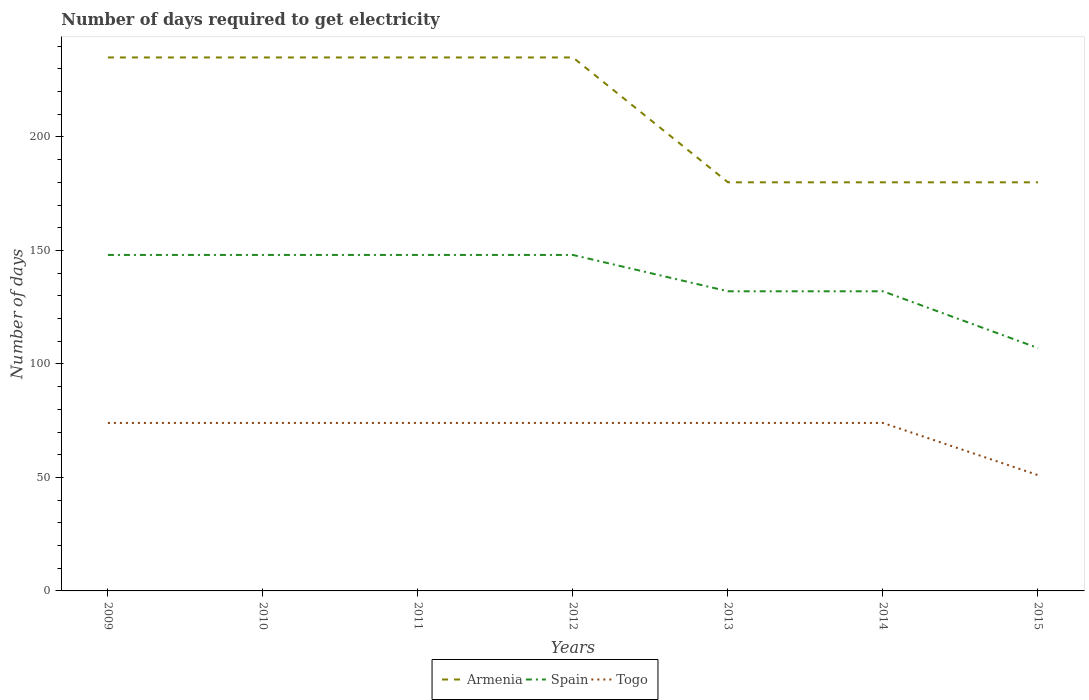How many different coloured lines are there?
Provide a succinct answer. 3. Is the number of lines equal to the number of legend labels?
Keep it short and to the point. Yes. Across all years, what is the maximum number of days required to get electricity in in Spain?
Provide a short and direct response. 107. What is the total number of days required to get electricity in in Togo in the graph?
Offer a terse response. 0. What is the difference between the highest and the second highest number of days required to get electricity in in Armenia?
Your response must be concise. 55. Is the number of days required to get electricity in in Spain strictly greater than the number of days required to get electricity in in Togo over the years?
Ensure brevity in your answer.  No. How many years are there in the graph?
Your response must be concise. 7. What is the difference between two consecutive major ticks on the Y-axis?
Provide a succinct answer. 50. Are the values on the major ticks of Y-axis written in scientific E-notation?
Ensure brevity in your answer.  No. Does the graph contain any zero values?
Your answer should be compact. No. Where does the legend appear in the graph?
Provide a succinct answer. Bottom center. How are the legend labels stacked?
Your answer should be compact. Horizontal. What is the title of the graph?
Your answer should be compact. Number of days required to get electricity. Does "Ethiopia" appear as one of the legend labels in the graph?
Your answer should be compact. No. What is the label or title of the Y-axis?
Keep it short and to the point. Number of days. What is the Number of days in Armenia in 2009?
Your answer should be compact. 235. What is the Number of days of Spain in 2009?
Give a very brief answer. 148. What is the Number of days of Armenia in 2010?
Your response must be concise. 235. What is the Number of days in Spain in 2010?
Ensure brevity in your answer.  148. What is the Number of days of Armenia in 2011?
Give a very brief answer. 235. What is the Number of days of Spain in 2011?
Provide a short and direct response. 148. What is the Number of days in Armenia in 2012?
Give a very brief answer. 235. What is the Number of days in Spain in 2012?
Your answer should be compact. 148. What is the Number of days of Armenia in 2013?
Ensure brevity in your answer.  180. What is the Number of days of Spain in 2013?
Provide a short and direct response. 132. What is the Number of days of Togo in 2013?
Your answer should be very brief. 74. What is the Number of days in Armenia in 2014?
Provide a short and direct response. 180. What is the Number of days of Spain in 2014?
Offer a terse response. 132. What is the Number of days in Armenia in 2015?
Make the answer very short. 180. What is the Number of days in Spain in 2015?
Offer a terse response. 107. Across all years, what is the maximum Number of days of Armenia?
Your response must be concise. 235. Across all years, what is the maximum Number of days in Spain?
Ensure brevity in your answer.  148. Across all years, what is the maximum Number of days in Togo?
Your answer should be very brief. 74. Across all years, what is the minimum Number of days in Armenia?
Ensure brevity in your answer.  180. Across all years, what is the minimum Number of days in Spain?
Your response must be concise. 107. What is the total Number of days of Armenia in the graph?
Give a very brief answer. 1480. What is the total Number of days in Spain in the graph?
Provide a succinct answer. 963. What is the total Number of days in Togo in the graph?
Offer a terse response. 495. What is the difference between the Number of days of Armenia in 2009 and that in 2010?
Make the answer very short. 0. What is the difference between the Number of days in Spain in 2009 and that in 2010?
Give a very brief answer. 0. What is the difference between the Number of days of Togo in 2009 and that in 2010?
Provide a short and direct response. 0. What is the difference between the Number of days of Armenia in 2009 and that in 2011?
Your answer should be compact. 0. What is the difference between the Number of days of Spain in 2009 and that in 2011?
Your response must be concise. 0. What is the difference between the Number of days of Togo in 2009 and that in 2011?
Provide a succinct answer. 0. What is the difference between the Number of days of Armenia in 2009 and that in 2012?
Your answer should be very brief. 0. What is the difference between the Number of days of Togo in 2009 and that in 2012?
Keep it short and to the point. 0. What is the difference between the Number of days of Armenia in 2009 and that in 2013?
Provide a succinct answer. 55. What is the difference between the Number of days of Togo in 2009 and that in 2013?
Offer a very short reply. 0. What is the difference between the Number of days in Armenia in 2009 and that in 2015?
Offer a very short reply. 55. What is the difference between the Number of days of Togo in 2009 and that in 2015?
Keep it short and to the point. 23. What is the difference between the Number of days in Armenia in 2010 and that in 2011?
Your answer should be compact. 0. What is the difference between the Number of days of Spain in 2010 and that in 2011?
Provide a short and direct response. 0. What is the difference between the Number of days in Togo in 2010 and that in 2011?
Keep it short and to the point. 0. What is the difference between the Number of days of Armenia in 2010 and that in 2012?
Keep it short and to the point. 0. What is the difference between the Number of days in Armenia in 2010 and that in 2013?
Your answer should be very brief. 55. What is the difference between the Number of days of Togo in 2010 and that in 2014?
Your answer should be compact. 0. What is the difference between the Number of days in Armenia in 2010 and that in 2015?
Offer a very short reply. 55. What is the difference between the Number of days of Togo in 2010 and that in 2015?
Ensure brevity in your answer.  23. What is the difference between the Number of days in Togo in 2011 and that in 2012?
Provide a short and direct response. 0. What is the difference between the Number of days in Armenia in 2011 and that in 2013?
Make the answer very short. 55. What is the difference between the Number of days of Spain in 2011 and that in 2013?
Offer a terse response. 16. What is the difference between the Number of days of Armenia in 2011 and that in 2014?
Ensure brevity in your answer.  55. What is the difference between the Number of days of Spain in 2011 and that in 2014?
Your answer should be very brief. 16. What is the difference between the Number of days of Armenia in 2011 and that in 2015?
Your answer should be very brief. 55. What is the difference between the Number of days of Togo in 2012 and that in 2013?
Offer a very short reply. 0. What is the difference between the Number of days of Armenia in 2012 and that in 2014?
Make the answer very short. 55. What is the difference between the Number of days of Spain in 2012 and that in 2014?
Keep it short and to the point. 16. What is the difference between the Number of days of Togo in 2012 and that in 2014?
Ensure brevity in your answer.  0. What is the difference between the Number of days of Armenia in 2012 and that in 2015?
Your answer should be compact. 55. What is the difference between the Number of days in Armenia in 2013 and that in 2014?
Your answer should be very brief. 0. What is the difference between the Number of days of Armenia in 2013 and that in 2015?
Your answer should be compact. 0. What is the difference between the Number of days in Spain in 2013 and that in 2015?
Provide a short and direct response. 25. What is the difference between the Number of days of Armenia in 2014 and that in 2015?
Offer a very short reply. 0. What is the difference between the Number of days in Spain in 2014 and that in 2015?
Ensure brevity in your answer.  25. What is the difference between the Number of days of Togo in 2014 and that in 2015?
Your answer should be very brief. 23. What is the difference between the Number of days in Armenia in 2009 and the Number of days in Spain in 2010?
Provide a succinct answer. 87. What is the difference between the Number of days in Armenia in 2009 and the Number of days in Togo in 2010?
Make the answer very short. 161. What is the difference between the Number of days in Spain in 2009 and the Number of days in Togo in 2010?
Ensure brevity in your answer.  74. What is the difference between the Number of days in Armenia in 2009 and the Number of days in Spain in 2011?
Make the answer very short. 87. What is the difference between the Number of days of Armenia in 2009 and the Number of days of Togo in 2011?
Your response must be concise. 161. What is the difference between the Number of days in Armenia in 2009 and the Number of days in Spain in 2012?
Your answer should be very brief. 87. What is the difference between the Number of days in Armenia in 2009 and the Number of days in Togo in 2012?
Provide a succinct answer. 161. What is the difference between the Number of days of Spain in 2009 and the Number of days of Togo in 2012?
Provide a succinct answer. 74. What is the difference between the Number of days in Armenia in 2009 and the Number of days in Spain in 2013?
Give a very brief answer. 103. What is the difference between the Number of days in Armenia in 2009 and the Number of days in Togo in 2013?
Your answer should be compact. 161. What is the difference between the Number of days in Armenia in 2009 and the Number of days in Spain in 2014?
Make the answer very short. 103. What is the difference between the Number of days of Armenia in 2009 and the Number of days of Togo in 2014?
Your answer should be very brief. 161. What is the difference between the Number of days of Spain in 2009 and the Number of days of Togo in 2014?
Keep it short and to the point. 74. What is the difference between the Number of days in Armenia in 2009 and the Number of days in Spain in 2015?
Provide a succinct answer. 128. What is the difference between the Number of days in Armenia in 2009 and the Number of days in Togo in 2015?
Provide a short and direct response. 184. What is the difference between the Number of days in Spain in 2009 and the Number of days in Togo in 2015?
Make the answer very short. 97. What is the difference between the Number of days in Armenia in 2010 and the Number of days in Spain in 2011?
Keep it short and to the point. 87. What is the difference between the Number of days of Armenia in 2010 and the Number of days of Togo in 2011?
Make the answer very short. 161. What is the difference between the Number of days in Armenia in 2010 and the Number of days in Spain in 2012?
Keep it short and to the point. 87. What is the difference between the Number of days in Armenia in 2010 and the Number of days in Togo in 2012?
Keep it short and to the point. 161. What is the difference between the Number of days of Armenia in 2010 and the Number of days of Spain in 2013?
Offer a terse response. 103. What is the difference between the Number of days in Armenia in 2010 and the Number of days in Togo in 2013?
Your response must be concise. 161. What is the difference between the Number of days in Spain in 2010 and the Number of days in Togo in 2013?
Ensure brevity in your answer.  74. What is the difference between the Number of days of Armenia in 2010 and the Number of days of Spain in 2014?
Your answer should be compact. 103. What is the difference between the Number of days of Armenia in 2010 and the Number of days of Togo in 2014?
Keep it short and to the point. 161. What is the difference between the Number of days in Spain in 2010 and the Number of days in Togo in 2014?
Keep it short and to the point. 74. What is the difference between the Number of days in Armenia in 2010 and the Number of days in Spain in 2015?
Give a very brief answer. 128. What is the difference between the Number of days of Armenia in 2010 and the Number of days of Togo in 2015?
Your answer should be compact. 184. What is the difference between the Number of days in Spain in 2010 and the Number of days in Togo in 2015?
Offer a terse response. 97. What is the difference between the Number of days in Armenia in 2011 and the Number of days in Togo in 2012?
Offer a very short reply. 161. What is the difference between the Number of days in Spain in 2011 and the Number of days in Togo in 2012?
Make the answer very short. 74. What is the difference between the Number of days of Armenia in 2011 and the Number of days of Spain in 2013?
Provide a short and direct response. 103. What is the difference between the Number of days in Armenia in 2011 and the Number of days in Togo in 2013?
Offer a terse response. 161. What is the difference between the Number of days in Spain in 2011 and the Number of days in Togo in 2013?
Give a very brief answer. 74. What is the difference between the Number of days in Armenia in 2011 and the Number of days in Spain in 2014?
Ensure brevity in your answer.  103. What is the difference between the Number of days in Armenia in 2011 and the Number of days in Togo in 2014?
Give a very brief answer. 161. What is the difference between the Number of days in Spain in 2011 and the Number of days in Togo in 2014?
Your answer should be compact. 74. What is the difference between the Number of days of Armenia in 2011 and the Number of days of Spain in 2015?
Your response must be concise. 128. What is the difference between the Number of days in Armenia in 2011 and the Number of days in Togo in 2015?
Make the answer very short. 184. What is the difference between the Number of days of Spain in 2011 and the Number of days of Togo in 2015?
Make the answer very short. 97. What is the difference between the Number of days of Armenia in 2012 and the Number of days of Spain in 2013?
Your answer should be very brief. 103. What is the difference between the Number of days in Armenia in 2012 and the Number of days in Togo in 2013?
Provide a succinct answer. 161. What is the difference between the Number of days of Spain in 2012 and the Number of days of Togo in 2013?
Give a very brief answer. 74. What is the difference between the Number of days in Armenia in 2012 and the Number of days in Spain in 2014?
Make the answer very short. 103. What is the difference between the Number of days in Armenia in 2012 and the Number of days in Togo in 2014?
Provide a short and direct response. 161. What is the difference between the Number of days in Armenia in 2012 and the Number of days in Spain in 2015?
Keep it short and to the point. 128. What is the difference between the Number of days of Armenia in 2012 and the Number of days of Togo in 2015?
Your response must be concise. 184. What is the difference between the Number of days in Spain in 2012 and the Number of days in Togo in 2015?
Your answer should be compact. 97. What is the difference between the Number of days in Armenia in 2013 and the Number of days in Spain in 2014?
Provide a succinct answer. 48. What is the difference between the Number of days of Armenia in 2013 and the Number of days of Togo in 2014?
Offer a very short reply. 106. What is the difference between the Number of days of Spain in 2013 and the Number of days of Togo in 2014?
Give a very brief answer. 58. What is the difference between the Number of days in Armenia in 2013 and the Number of days in Togo in 2015?
Ensure brevity in your answer.  129. What is the difference between the Number of days in Armenia in 2014 and the Number of days in Togo in 2015?
Offer a very short reply. 129. What is the average Number of days in Armenia per year?
Provide a short and direct response. 211.43. What is the average Number of days of Spain per year?
Provide a succinct answer. 137.57. What is the average Number of days in Togo per year?
Your answer should be very brief. 70.71. In the year 2009, what is the difference between the Number of days in Armenia and Number of days in Spain?
Keep it short and to the point. 87. In the year 2009, what is the difference between the Number of days in Armenia and Number of days in Togo?
Keep it short and to the point. 161. In the year 2010, what is the difference between the Number of days of Armenia and Number of days of Spain?
Offer a very short reply. 87. In the year 2010, what is the difference between the Number of days in Armenia and Number of days in Togo?
Offer a terse response. 161. In the year 2011, what is the difference between the Number of days of Armenia and Number of days of Togo?
Your response must be concise. 161. In the year 2012, what is the difference between the Number of days of Armenia and Number of days of Spain?
Offer a terse response. 87. In the year 2012, what is the difference between the Number of days of Armenia and Number of days of Togo?
Provide a succinct answer. 161. In the year 2013, what is the difference between the Number of days in Armenia and Number of days in Togo?
Provide a short and direct response. 106. In the year 2013, what is the difference between the Number of days in Spain and Number of days in Togo?
Your response must be concise. 58. In the year 2014, what is the difference between the Number of days in Armenia and Number of days in Spain?
Provide a succinct answer. 48. In the year 2014, what is the difference between the Number of days of Armenia and Number of days of Togo?
Offer a terse response. 106. In the year 2015, what is the difference between the Number of days of Armenia and Number of days of Togo?
Offer a very short reply. 129. What is the ratio of the Number of days in Armenia in 2009 to that in 2010?
Make the answer very short. 1. What is the ratio of the Number of days in Armenia in 2009 to that in 2011?
Your answer should be very brief. 1. What is the ratio of the Number of days of Spain in 2009 to that in 2011?
Make the answer very short. 1. What is the ratio of the Number of days of Armenia in 2009 to that in 2012?
Provide a succinct answer. 1. What is the ratio of the Number of days of Spain in 2009 to that in 2012?
Provide a succinct answer. 1. What is the ratio of the Number of days in Togo in 2009 to that in 2012?
Offer a very short reply. 1. What is the ratio of the Number of days in Armenia in 2009 to that in 2013?
Your answer should be very brief. 1.31. What is the ratio of the Number of days of Spain in 2009 to that in 2013?
Provide a short and direct response. 1.12. What is the ratio of the Number of days of Armenia in 2009 to that in 2014?
Offer a terse response. 1.31. What is the ratio of the Number of days of Spain in 2009 to that in 2014?
Offer a terse response. 1.12. What is the ratio of the Number of days in Armenia in 2009 to that in 2015?
Make the answer very short. 1.31. What is the ratio of the Number of days in Spain in 2009 to that in 2015?
Offer a very short reply. 1.38. What is the ratio of the Number of days in Togo in 2009 to that in 2015?
Your answer should be very brief. 1.45. What is the ratio of the Number of days in Armenia in 2010 to that in 2011?
Make the answer very short. 1. What is the ratio of the Number of days in Togo in 2010 to that in 2011?
Make the answer very short. 1. What is the ratio of the Number of days in Armenia in 2010 to that in 2012?
Offer a terse response. 1. What is the ratio of the Number of days in Spain in 2010 to that in 2012?
Give a very brief answer. 1. What is the ratio of the Number of days in Togo in 2010 to that in 2012?
Offer a terse response. 1. What is the ratio of the Number of days of Armenia in 2010 to that in 2013?
Provide a short and direct response. 1.31. What is the ratio of the Number of days of Spain in 2010 to that in 2013?
Make the answer very short. 1.12. What is the ratio of the Number of days in Togo in 2010 to that in 2013?
Your answer should be very brief. 1. What is the ratio of the Number of days in Armenia in 2010 to that in 2014?
Provide a short and direct response. 1.31. What is the ratio of the Number of days of Spain in 2010 to that in 2014?
Give a very brief answer. 1.12. What is the ratio of the Number of days in Togo in 2010 to that in 2014?
Give a very brief answer. 1. What is the ratio of the Number of days of Armenia in 2010 to that in 2015?
Offer a very short reply. 1.31. What is the ratio of the Number of days in Spain in 2010 to that in 2015?
Offer a terse response. 1.38. What is the ratio of the Number of days in Togo in 2010 to that in 2015?
Give a very brief answer. 1.45. What is the ratio of the Number of days in Armenia in 2011 to that in 2012?
Keep it short and to the point. 1. What is the ratio of the Number of days of Armenia in 2011 to that in 2013?
Provide a succinct answer. 1.31. What is the ratio of the Number of days of Spain in 2011 to that in 2013?
Make the answer very short. 1.12. What is the ratio of the Number of days of Togo in 2011 to that in 2013?
Ensure brevity in your answer.  1. What is the ratio of the Number of days in Armenia in 2011 to that in 2014?
Offer a very short reply. 1.31. What is the ratio of the Number of days in Spain in 2011 to that in 2014?
Provide a short and direct response. 1.12. What is the ratio of the Number of days in Togo in 2011 to that in 2014?
Give a very brief answer. 1. What is the ratio of the Number of days in Armenia in 2011 to that in 2015?
Provide a succinct answer. 1.31. What is the ratio of the Number of days of Spain in 2011 to that in 2015?
Offer a terse response. 1.38. What is the ratio of the Number of days of Togo in 2011 to that in 2015?
Offer a very short reply. 1.45. What is the ratio of the Number of days in Armenia in 2012 to that in 2013?
Provide a succinct answer. 1.31. What is the ratio of the Number of days of Spain in 2012 to that in 2013?
Offer a terse response. 1.12. What is the ratio of the Number of days of Armenia in 2012 to that in 2014?
Provide a short and direct response. 1.31. What is the ratio of the Number of days in Spain in 2012 to that in 2014?
Your answer should be compact. 1.12. What is the ratio of the Number of days of Armenia in 2012 to that in 2015?
Ensure brevity in your answer.  1.31. What is the ratio of the Number of days in Spain in 2012 to that in 2015?
Keep it short and to the point. 1.38. What is the ratio of the Number of days in Togo in 2012 to that in 2015?
Provide a succinct answer. 1.45. What is the ratio of the Number of days in Armenia in 2013 to that in 2014?
Provide a succinct answer. 1. What is the ratio of the Number of days of Togo in 2013 to that in 2014?
Ensure brevity in your answer.  1. What is the ratio of the Number of days of Spain in 2013 to that in 2015?
Offer a terse response. 1.23. What is the ratio of the Number of days of Togo in 2013 to that in 2015?
Your response must be concise. 1.45. What is the ratio of the Number of days of Spain in 2014 to that in 2015?
Your answer should be very brief. 1.23. What is the ratio of the Number of days of Togo in 2014 to that in 2015?
Give a very brief answer. 1.45. 